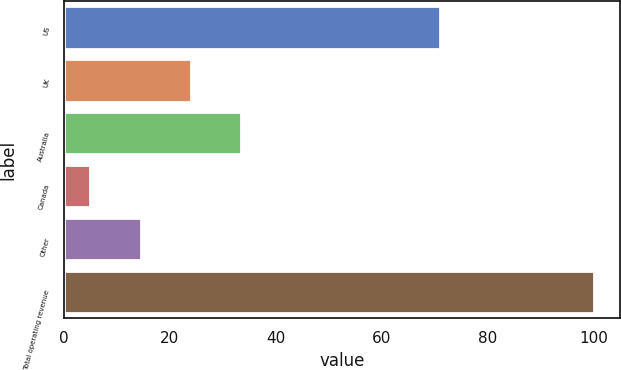<chart> <loc_0><loc_0><loc_500><loc_500><bar_chart><fcel>US<fcel>UK<fcel>Australia<fcel>Canada<fcel>Other<fcel>Total operating revenue<nl><fcel>71<fcel>24<fcel>33.5<fcel>5<fcel>14.5<fcel>100<nl></chart> 